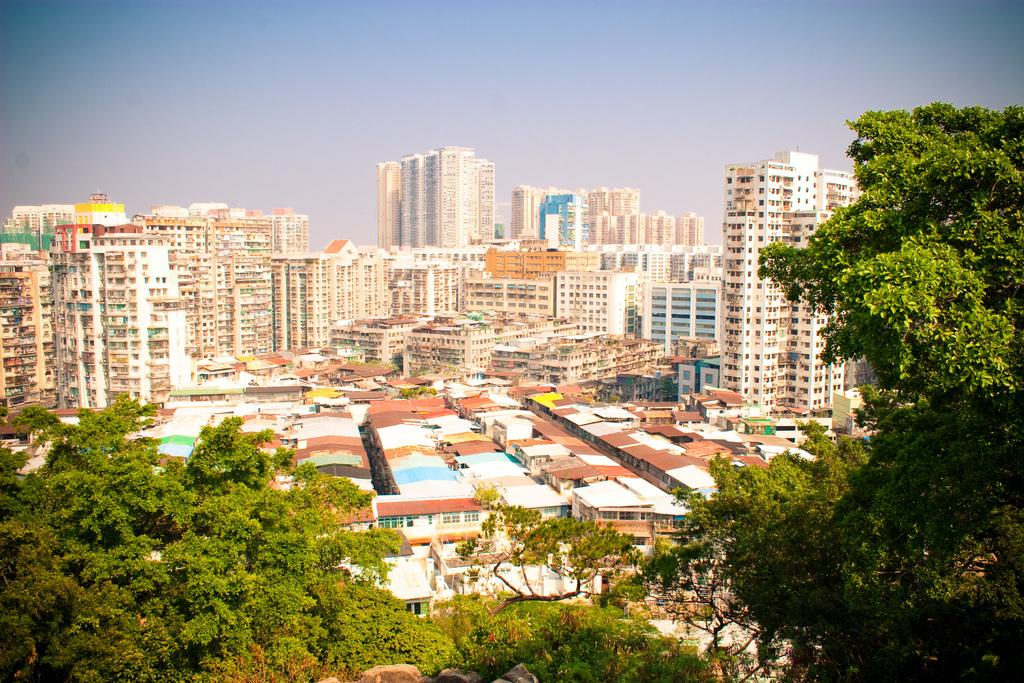What type of natural elements can be seen in the image? There are trees in the image. What type of man-made structures are visible in the background? There are buildings in the background of the image. What part of the natural environment is visible in the image? The sky is visible in the background of the image. What type of ear is visible on the tree in the image? There are no ears present in the image; it features trees and buildings. How many bulbs can be seen hanging from the branches of the trees in the image? There are no bulbs present in the image; it features trees and buildings. 